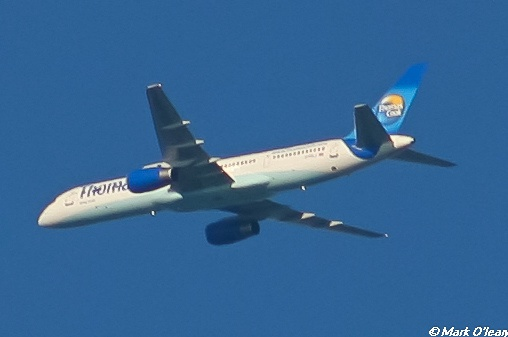Describe the objects in this image and their specific colors. I can see a airplane in blue, darkblue, and beige tones in this image. 